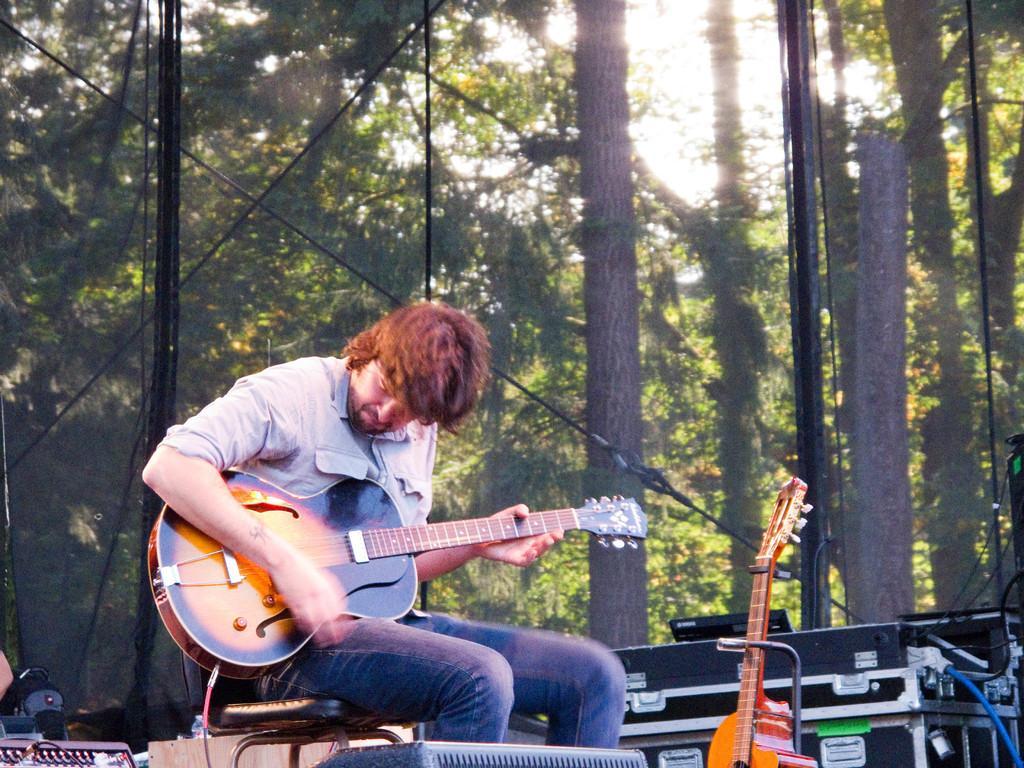Can you describe this image briefly? In this image there is a person sitting on a chair playing a guitar. Beside him there is another guitar. At the background there are few trees. At the right bottom there are few electrical device. 